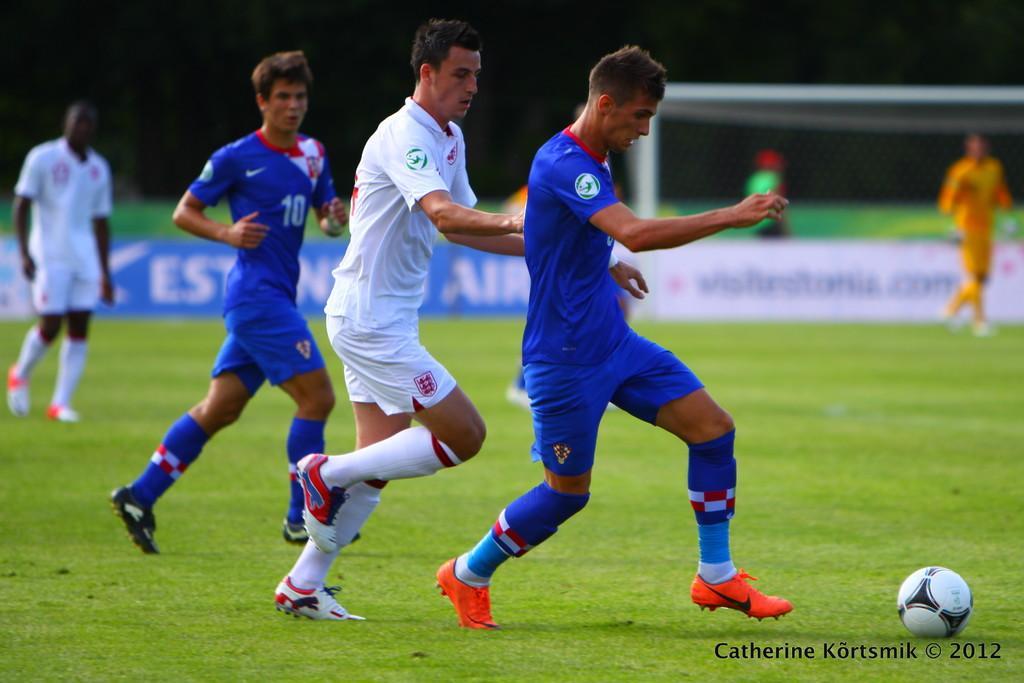Could you give a brief overview of what you see in this image? In the image there are few players in blue dress and few persons in white dress running on grass field behind a football, in the back there is goalpost on the right side with a person standing in front of it in yellow dress. 